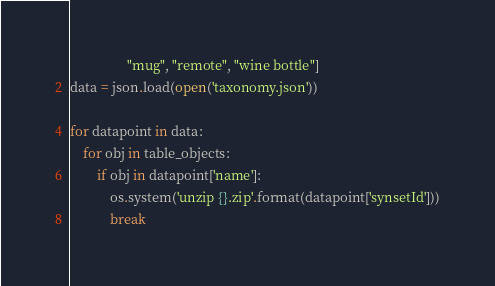Convert code to text. <code><loc_0><loc_0><loc_500><loc_500><_Python_>                 "mug", "remote", "wine bottle"]
data = json.load(open('taxonomy.json'))

for datapoint in data:
    for obj in table_objects:
        if obj in datapoint['name']:
            os.system('unzip {}.zip'.format(datapoint['synsetId']))
            break</code> 